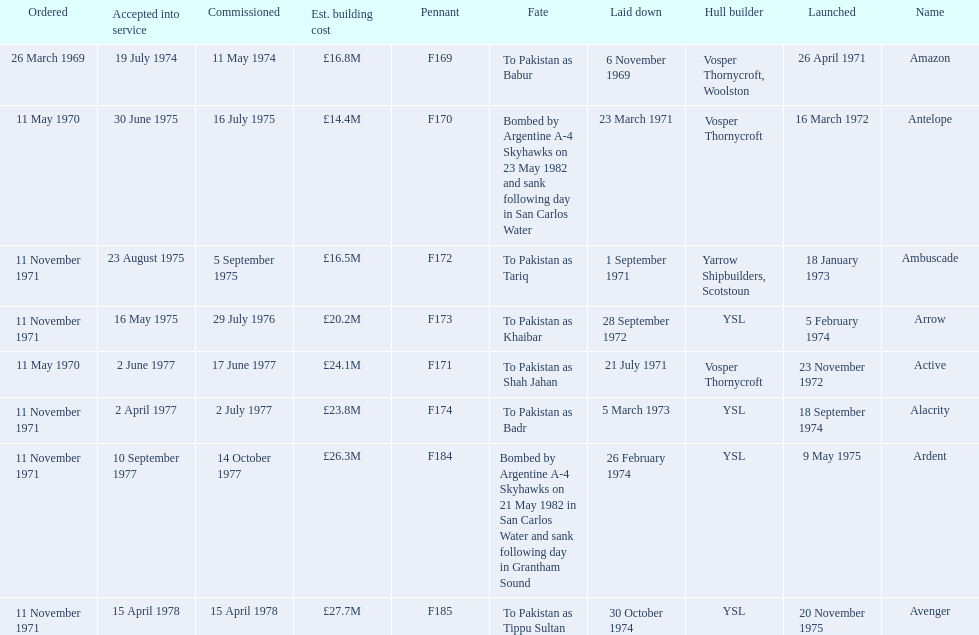Which type 21 frigate ships were to be built by ysl in the 1970s? Arrow, Alacrity, Ardent, Avenger. Of these ships, which one had the highest estimated building cost? Avenger. 